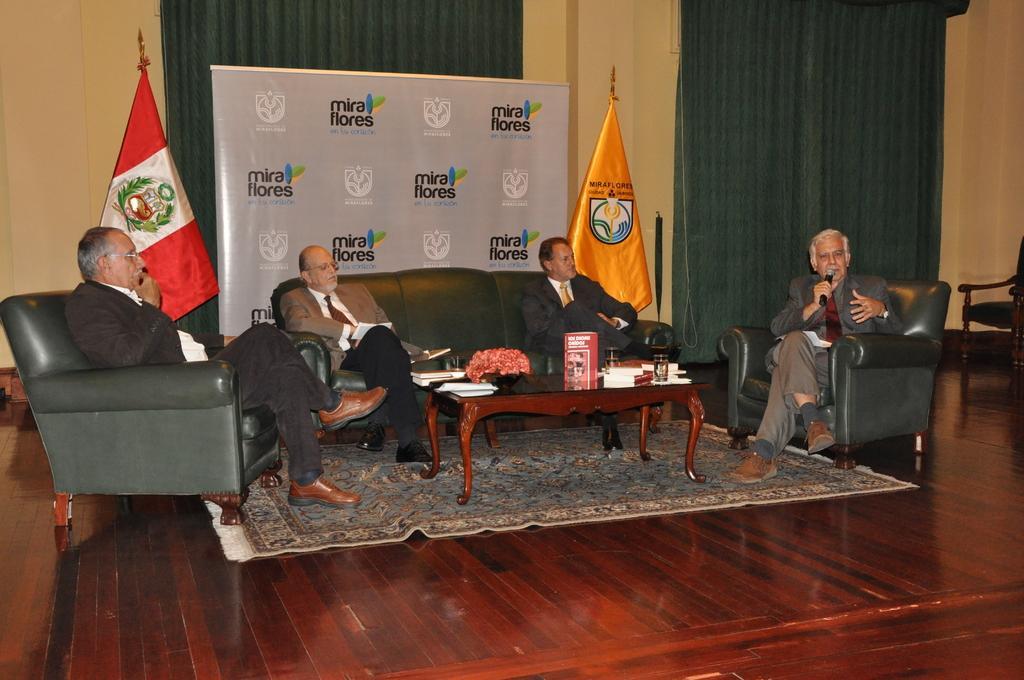Please provide a concise description of this image. In this picture we can see four men are sitting, there is a table in front of them, we can see some books and a glass present on the table, in the background we can see flags, a banner, curtains and a wall, we can see logos and some text present on the banner, a man on the right side is holding a mike, we can also see a chair on the right side. 